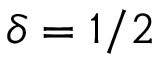Convert formula to latex. <formula><loc_0><loc_0><loc_500><loc_500>\delta = 1 / 2</formula> 